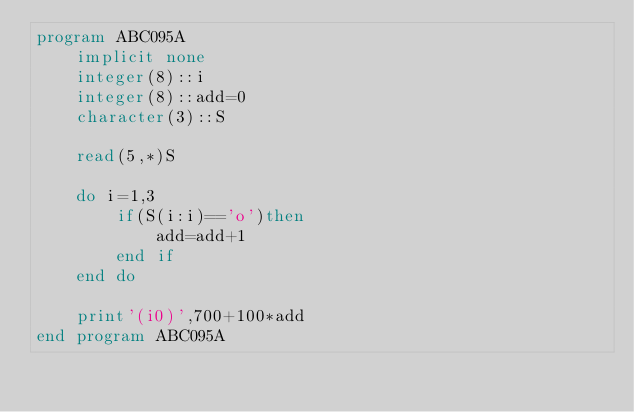Convert code to text. <code><loc_0><loc_0><loc_500><loc_500><_FORTRAN_>program ABC095A
    implicit none
    integer(8)::i
    integer(8)::add=0
    character(3)::S

    read(5,*)S

    do i=1,3
        if(S(i:i)=='o')then
            add=add+1
        end if
    end do

    print'(i0)',700+100*add
end program ABC095A</code> 